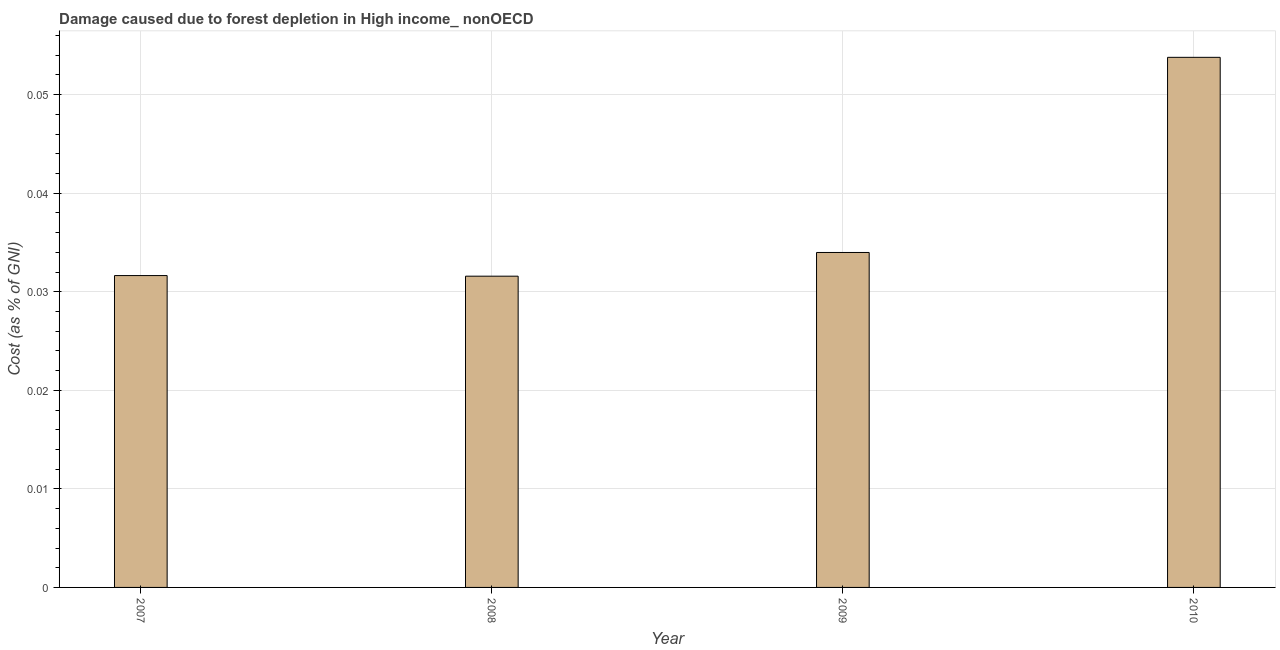Does the graph contain grids?
Your answer should be very brief. Yes. What is the title of the graph?
Provide a short and direct response. Damage caused due to forest depletion in High income_ nonOECD. What is the label or title of the Y-axis?
Provide a succinct answer. Cost (as % of GNI). What is the damage caused due to forest depletion in 2010?
Your answer should be very brief. 0.05. Across all years, what is the maximum damage caused due to forest depletion?
Ensure brevity in your answer.  0.05. Across all years, what is the minimum damage caused due to forest depletion?
Your response must be concise. 0.03. In which year was the damage caused due to forest depletion maximum?
Provide a short and direct response. 2010. In which year was the damage caused due to forest depletion minimum?
Keep it short and to the point. 2008. What is the sum of the damage caused due to forest depletion?
Offer a very short reply. 0.15. What is the difference between the damage caused due to forest depletion in 2007 and 2009?
Your response must be concise. -0. What is the average damage caused due to forest depletion per year?
Your answer should be compact. 0.04. What is the median damage caused due to forest depletion?
Provide a succinct answer. 0.03. Is the difference between the damage caused due to forest depletion in 2007 and 2008 greater than the difference between any two years?
Your answer should be compact. No. Is the sum of the damage caused due to forest depletion in 2007 and 2010 greater than the maximum damage caused due to forest depletion across all years?
Your answer should be compact. Yes. What is the difference between the highest and the lowest damage caused due to forest depletion?
Your answer should be very brief. 0.02. In how many years, is the damage caused due to forest depletion greater than the average damage caused due to forest depletion taken over all years?
Offer a very short reply. 1. How many years are there in the graph?
Offer a very short reply. 4. What is the Cost (as % of GNI) in 2007?
Offer a terse response. 0.03. What is the Cost (as % of GNI) of 2008?
Keep it short and to the point. 0.03. What is the Cost (as % of GNI) of 2009?
Give a very brief answer. 0.03. What is the Cost (as % of GNI) in 2010?
Offer a very short reply. 0.05. What is the difference between the Cost (as % of GNI) in 2007 and 2008?
Offer a very short reply. 6e-5. What is the difference between the Cost (as % of GNI) in 2007 and 2009?
Give a very brief answer. -0. What is the difference between the Cost (as % of GNI) in 2007 and 2010?
Your answer should be very brief. -0.02. What is the difference between the Cost (as % of GNI) in 2008 and 2009?
Your answer should be compact. -0. What is the difference between the Cost (as % of GNI) in 2008 and 2010?
Your response must be concise. -0.02. What is the difference between the Cost (as % of GNI) in 2009 and 2010?
Make the answer very short. -0.02. What is the ratio of the Cost (as % of GNI) in 2007 to that in 2008?
Give a very brief answer. 1. What is the ratio of the Cost (as % of GNI) in 2007 to that in 2009?
Keep it short and to the point. 0.93. What is the ratio of the Cost (as % of GNI) in 2007 to that in 2010?
Give a very brief answer. 0.59. What is the ratio of the Cost (as % of GNI) in 2008 to that in 2009?
Ensure brevity in your answer.  0.93. What is the ratio of the Cost (as % of GNI) in 2008 to that in 2010?
Provide a succinct answer. 0.59. What is the ratio of the Cost (as % of GNI) in 2009 to that in 2010?
Your answer should be compact. 0.63. 